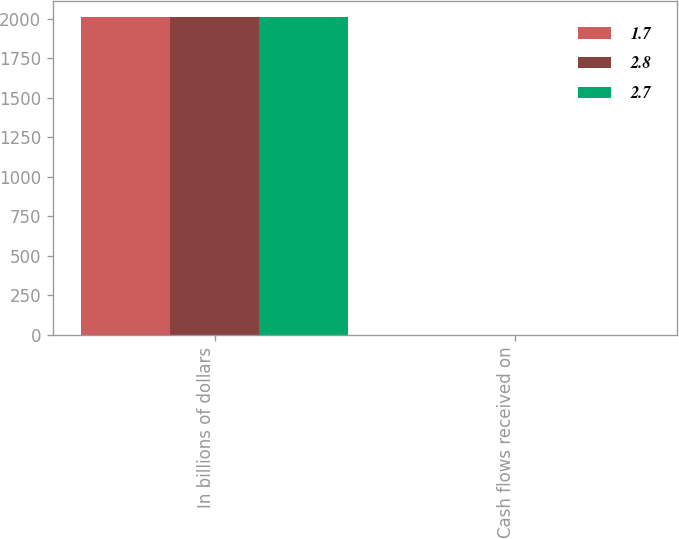Convert chart. <chart><loc_0><loc_0><loc_500><loc_500><stacked_bar_chart><ecel><fcel>In billions of dollars<fcel>Cash flows received on<nl><fcel>1.7<fcel>2010<fcel>2.8<nl><fcel>2.8<fcel>2009<fcel>2.7<nl><fcel>2.7<fcel>2008<fcel>1.7<nl></chart> 